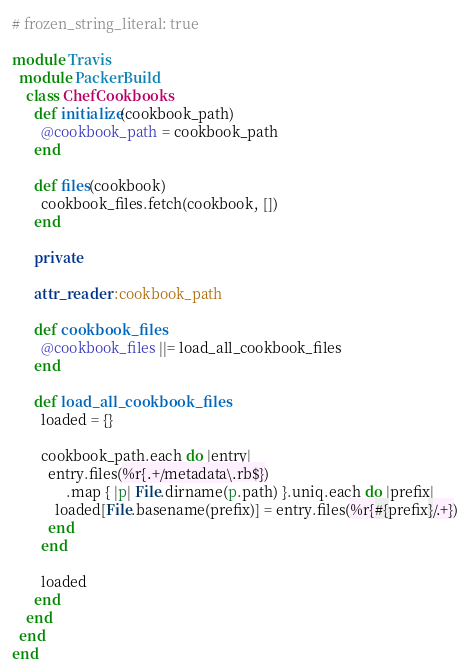Convert code to text. <code><loc_0><loc_0><loc_500><loc_500><_Ruby_># frozen_string_literal: true

module Travis
  module PackerBuild
    class ChefCookbooks
      def initialize(cookbook_path)
        @cookbook_path = cookbook_path
      end

      def files(cookbook)
        cookbook_files.fetch(cookbook, [])
      end

      private

      attr_reader :cookbook_path

      def cookbook_files
        @cookbook_files ||= load_all_cookbook_files
      end

      def load_all_cookbook_files
        loaded = {}

        cookbook_path.each do |entry|
          entry.files(%r{.+/metadata\.rb$})
               .map { |p| File.dirname(p.path) }.uniq.each do |prefix|
            loaded[File.basename(prefix)] = entry.files(%r{#{prefix}/.+})
          end
        end

        loaded
      end
    end
  end
end
</code> 